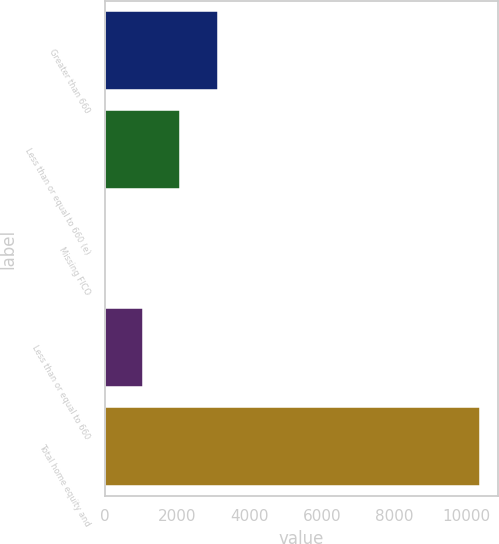Convert chart. <chart><loc_0><loc_0><loc_500><loc_500><bar_chart><fcel>Greater than 660<fcel>Less than or equal to 660 (e)<fcel>Missing FICO<fcel>Less than or equal to 660<fcel>Total home equity and<nl><fcel>3119.5<fcel>2085<fcel>16<fcel>1050.5<fcel>10361<nl></chart> 